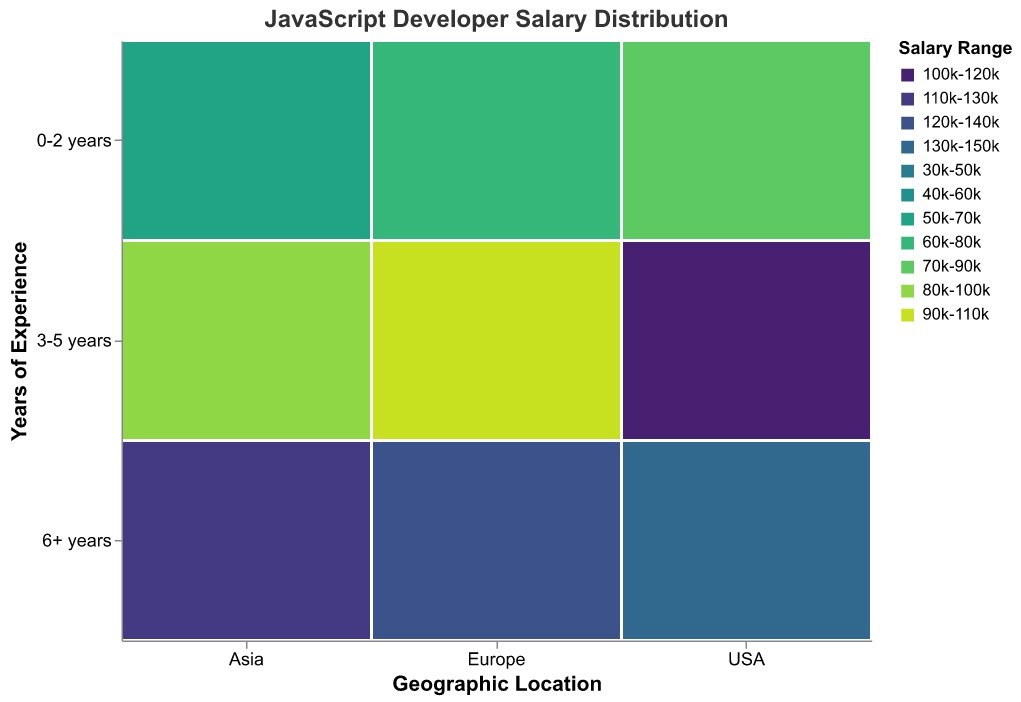What is the title of the figure? The title is usually displayed at the top of the figure. For this plot, it specifies the primary focus, which is "JavaScript Developer Salary Distribution".
Answer: JavaScript Developer Salary Distribution Which location has the highest count of developers with 0-2 years of experience in the 30k-50k salary range? By looking at the regions and filtering for those with 0-2 years of experience and a salary range of 30k-50k, you will see that this only applies to Asia. The highest count in this segment is 140.
Answer: Asia What is the most common salary range for developers in the USA with 3-5 years of experience? In the plot, locate the USA section and find the "3-5 years" row. Then, identify the largest block within this row, which represents the common salary range. For "3-5 years" experience in USA, the most common salary range is "80k-100k".
Answer: 80k-100k Compare the count of developers in Europe with 6+ years of experience earning 120k-140k to those in the USA within the same experience and salary range. Which is higher? Navigate to the Europe section and find the 6+ years row and the salary block for 120k-140k, then compare it with the corresponding section in the USA. The count in Europe is 60 while in the USA it is absent. Hence, Europe has a higher count.
Answer: Europe What is the total number of developers with 0-2 years of experience across all locations? Add up all the counts of developers with 0-2 years of experience: USA (120+80), Europe (100+70), and Asia (140+90). This totals to 320.
Answer: 320 Identify which geographic location has the lowest count of developers with 6+ years of experience in the 90k-110k salary range? Check each location for developers with 6+ years of experience earning 90k-110k. You will find these values are: USA (90), Europe (60), and Asia (70). Hence, Europe has the lowest count.
Answer: Europe What is the difference in the number of developers between those with 0-2 years of experience in Europe and Asia within the 60k-80k salary range? For 0-2 years of experience with a salary range of 60k-80k, identify the counts: Europe (70) and Asia (not applicable). Subtracting 0 from 70 gives 70.
Answer: 70 In which experience category do developers in the USA have the greatest variety of salary ranges? Examine each experience level within the USA and count the distinct salary range blocks. The level with the most distinct blocks represents the greatest variety. For USA, "0-2 years" and "3-5 years" both show two distinct ranges, so either can be correct.
Answer: 0-2 years and 3-5 years How does the count of developers in Asia with 3-5 years of experience and a salary range of 80k-100k compare to those in Europe with the same experience and salary range? Look at the counts for Asia and Europe in the relevant categories. Asia has 80 developers while Europe has 90 developers. Hence, Europe has a higher count.
Answer: Europe 